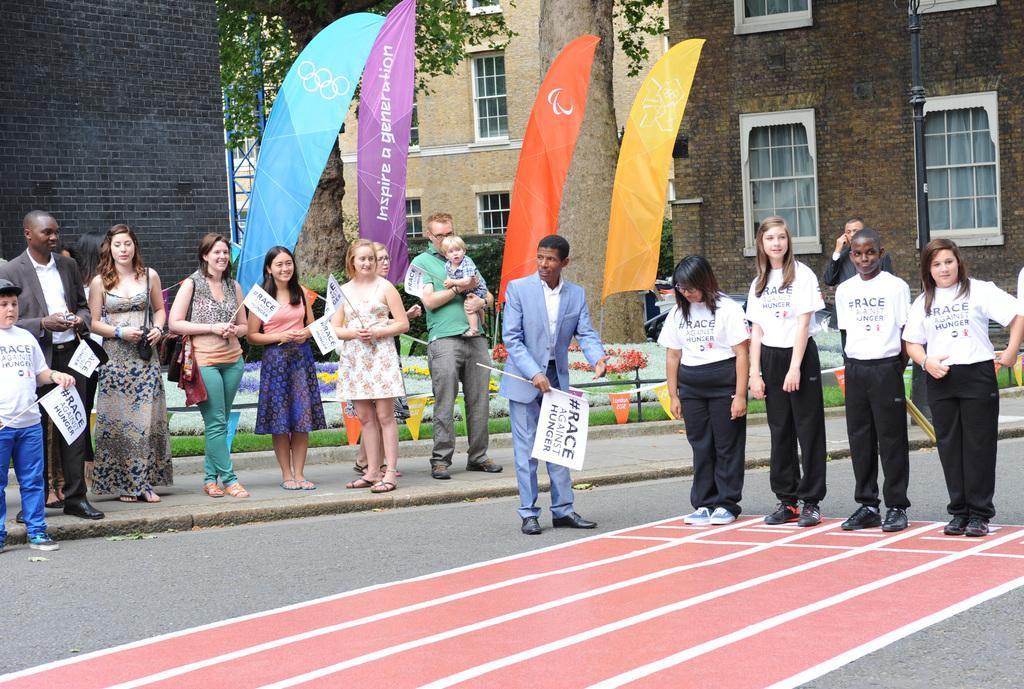How would you summarize this image in a sentence or two? In this image in the center there are a group of people who are standing and some of them are holding some placards, at the bottom there is a road. In the background there are some houses and trees and one tower. 